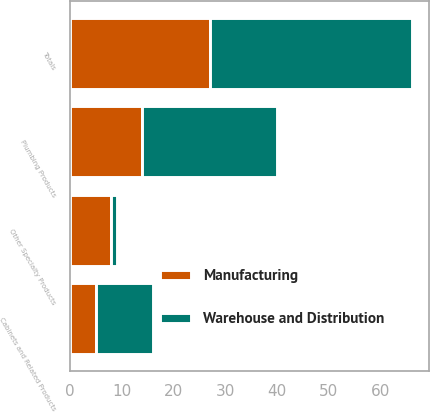Convert chart. <chart><loc_0><loc_0><loc_500><loc_500><stacked_bar_chart><ecel><fcel>Cabinets and Related Products<fcel>Plumbing Products<fcel>Other Specialty Products<fcel>Totals<nl><fcel>Manufacturing<fcel>5<fcel>14<fcel>8<fcel>27<nl><fcel>Warehouse and Distribution<fcel>11<fcel>26<fcel>1<fcel>39<nl></chart> 